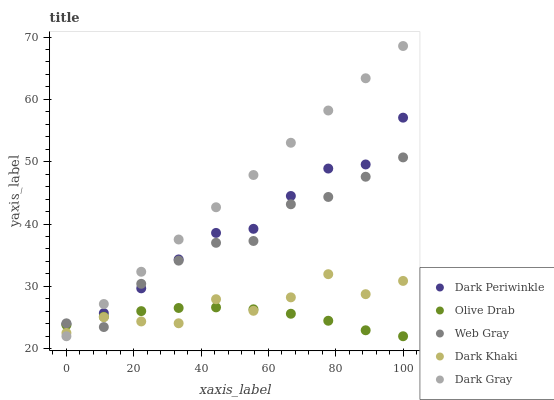Does Olive Drab have the minimum area under the curve?
Answer yes or no. Yes. Does Dark Gray have the maximum area under the curve?
Answer yes or no. Yes. Does Web Gray have the minimum area under the curve?
Answer yes or no. No. Does Web Gray have the maximum area under the curve?
Answer yes or no. No. Is Dark Gray the smoothest?
Answer yes or no. Yes. Is Dark Khaki the roughest?
Answer yes or no. Yes. Is Web Gray the smoothest?
Answer yes or no. No. Is Web Gray the roughest?
Answer yes or no. No. Does Dark Gray have the lowest value?
Answer yes or no. Yes. Does Web Gray have the lowest value?
Answer yes or no. No. Does Dark Gray have the highest value?
Answer yes or no. Yes. Does Web Gray have the highest value?
Answer yes or no. No. Is Dark Khaki less than Dark Periwinkle?
Answer yes or no. Yes. Is Dark Periwinkle greater than Dark Khaki?
Answer yes or no. Yes. Does Dark Khaki intersect Web Gray?
Answer yes or no. Yes. Is Dark Khaki less than Web Gray?
Answer yes or no. No. Is Dark Khaki greater than Web Gray?
Answer yes or no. No. Does Dark Khaki intersect Dark Periwinkle?
Answer yes or no. No. 